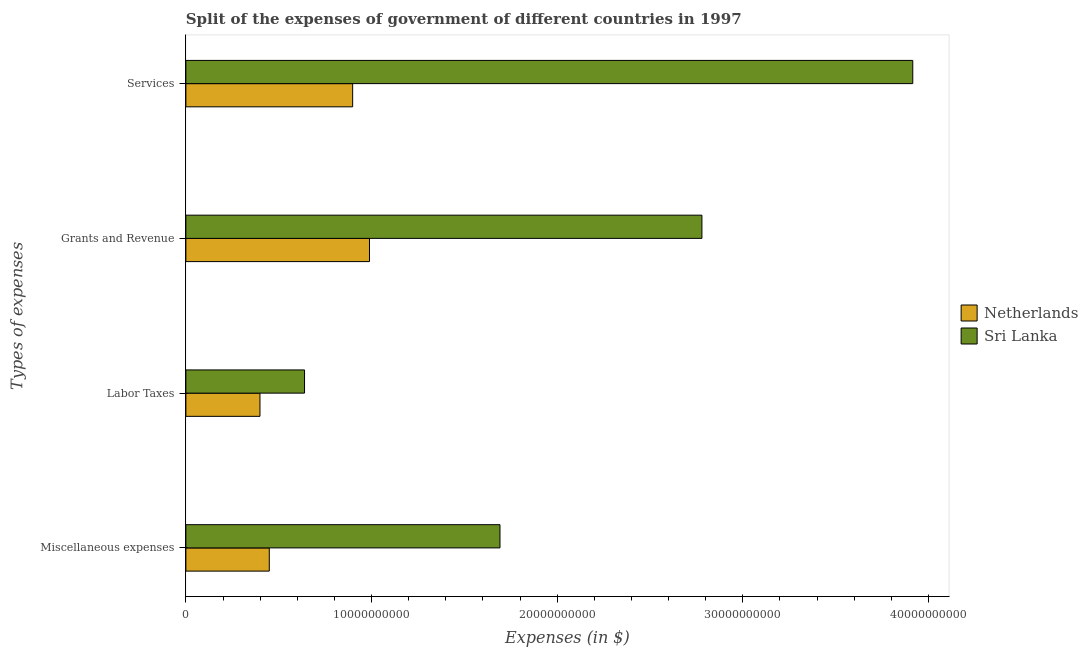How many different coloured bars are there?
Provide a succinct answer. 2. How many groups of bars are there?
Make the answer very short. 4. How many bars are there on the 3rd tick from the top?
Make the answer very short. 2. What is the label of the 1st group of bars from the top?
Keep it short and to the point. Services. What is the amount spent on grants and revenue in Sri Lanka?
Offer a very short reply. 2.78e+1. Across all countries, what is the maximum amount spent on miscellaneous expenses?
Ensure brevity in your answer.  1.69e+1. Across all countries, what is the minimum amount spent on labor taxes?
Provide a short and direct response. 3.99e+09. In which country was the amount spent on grants and revenue maximum?
Ensure brevity in your answer.  Sri Lanka. In which country was the amount spent on services minimum?
Make the answer very short. Netherlands. What is the total amount spent on labor taxes in the graph?
Offer a terse response. 1.04e+1. What is the difference between the amount spent on services in Sri Lanka and that in Netherlands?
Provide a succinct answer. 3.02e+1. What is the difference between the amount spent on miscellaneous expenses in Sri Lanka and the amount spent on labor taxes in Netherlands?
Give a very brief answer. 1.29e+1. What is the average amount spent on miscellaneous expenses per country?
Give a very brief answer. 1.07e+1. What is the difference between the amount spent on miscellaneous expenses and amount spent on grants and revenue in Sri Lanka?
Your answer should be compact. -1.09e+1. What is the ratio of the amount spent on grants and revenue in Netherlands to that in Sri Lanka?
Offer a terse response. 0.36. Is the amount spent on services in Netherlands less than that in Sri Lanka?
Your answer should be very brief. Yes. What is the difference between the highest and the second highest amount spent on miscellaneous expenses?
Provide a short and direct response. 1.24e+1. What is the difference between the highest and the lowest amount spent on miscellaneous expenses?
Your answer should be compact. 1.24e+1. In how many countries, is the amount spent on services greater than the average amount spent on services taken over all countries?
Your answer should be compact. 1. What does the 2nd bar from the top in Grants and Revenue represents?
Keep it short and to the point. Netherlands. Are all the bars in the graph horizontal?
Offer a terse response. Yes. How many countries are there in the graph?
Your response must be concise. 2. Are the values on the major ticks of X-axis written in scientific E-notation?
Make the answer very short. No. Does the graph contain any zero values?
Your answer should be compact. No. Where does the legend appear in the graph?
Make the answer very short. Center right. How many legend labels are there?
Provide a succinct answer. 2. What is the title of the graph?
Keep it short and to the point. Split of the expenses of government of different countries in 1997. Does "Australia" appear as one of the legend labels in the graph?
Your answer should be compact. No. What is the label or title of the X-axis?
Make the answer very short. Expenses (in $). What is the label or title of the Y-axis?
Keep it short and to the point. Types of expenses. What is the Expenses (in $) in Netherlands in Miscellaneous expenses?
Offer a very short reply. 4.49e+09. What is the Expenses (in $) of Sri Lanka in Miscellaneous expenses?
Give a very brief answer. 1.69e+1. What is the Expenses (in $) in Netherlands in Labor Taxes?
Ensure brevity in your answer.  3.99e+09. What is the Expenses (in $) of Sri Lanka in Labor Taxes?
Your answer should be compact. 6.39e+09. What is the Expenses (in $) of Netherlands in Grants and Revenue?
Ensure brevity in your answer.  9.89e+09. What is the Expenses (in $) of Sri Lanka in Grants and Revenue?
Provide a short and direct response. 2.78e+1. What is the Expenses (in $) of Netherlands in Services?
Ensure brevity in your answer.  8.98e+09. What is the Expenses (in $) in Sri Lanka in Services?
Offer a terse response. 3.92e+1. Across all Types of expenses, what is the maximum Expenses (in $) in Netherlands?
Ensure brevity in your answer.  9.89e+09. Across all Types of expenses, what is the maximum Expenses (in $) of Sri Lanka?
Offer a very short reply. 3.92e+1. Across all Types of expenses, what is the minimum Expenses (in $) of Netherlands?
Keep it short and to the point. 3.99e+09. Across all Types of expenses, what is the minimum Expenses (in $) of Sri Lanka?
Your answer should be very brief. 6.39e+09. What is the total Expenses (in $) of Netherlands in the graph?
Provide a short and direct response. 2.74e+1. What is the total Expenses (in $) in Sri Lanka in the graph?
Your answer should be very brief. 9.03e+1. What is the difference between the Expenses (in $) in Netherlands in Miscellaneous expenses and that in Labor Taxes?
Your answer should be compact. 5.02e+08. What is the difference between the Expenses (in $) of Sri Lanka in Miscellaneous expenses and that in Labor Taxes?
Make the answer very short. 1.05e+1. What is the difference between the Expenses (in $) in Netherlands in Miscellaneous expenses and that in Grants and Revenue?
Provide a succinct answer. -5.40e+09. What is the difference between the Expenses (in $) of Sri Lanka in Miscellaneous expenses and that in Grants and Revenue?
Your answer should be compact. -1.09e+1. What is the difference between the Expenses (in $) of Netherlands in Miscellaneous expenses and that in Services?
Give a very brief answer. -4.49e+09. What is the difference between the Expenses (in $) in Sri Lanka in Miscellaneous expenses and that in Services?
Give a very brief answer. -2.22e+1. What is the difference between the Expenses (in $) of Netherlands in Labor Taxes and that in Grants and Revenue?
Ensure brevity in your answer.  -5.90e+09. What is the difference between the Expenses (in $) of Sri Lanka in Labor Taxes and that in Grants and Revenue?
Keep it short and to the point. -2.14e+1. What is the difference between the Expenses (in $) in Netherlands in Labor Taxes and that in Services?
Your answer should be very brief. -4.99e+09. What is the difference between the Expenses (in $) in Sri Lanka in Labor Taxes and that in Services?
Give a very brief answer. -3.28e+1. What is the difference between the Expenses (in $) in Netherlands in Grants and Revenue and that in Services?
Keep it short and to the point. 9.07e+08. What is the difference between the Expenses (in $) in Sri Lanka in Grants and Revenue and that in Services?
Offer a very short reply. -1.14e+1. What is the difference between the Expenses (in $) of Netherlands in Miscellaneous expenses and the Expenses (in $) of Sri Lanka in Labor Taxes?
Give a very brief answer. -1.90e+09. What is the difference between the Expenses (in $) in Netherlands in Miscellaneous expenses and the Expenses (in $) in Sri Lanka in Grants and Revenue?
Offer a very short reply. -2.33e+1. What is the difference between the Expenses (in $) of Netherlands in Miscellaneous expenses and the Expenses (in $) of Sri Lanka in Services?
Make the answer very short. -3.47e+1. What is the difference between the Expenses (in $) of Netherlands in Labor Taxes and the Expenses (in $) of Sri Lanka in Grants and Revenue?
Offer a very short reply. -2.38e+1. What is the difference between the Expenses (in $) in Netherlands in Labor Taxes and the Expenses (in $) in Sri Lanka in Services?
Your response must be concise. -3.52e+1. What is the difference between the Expenses (in $) in Netherlands in Grants and Revenue and the Expenses (in $) in Sri Lanka in Services?
Offer a terse response. -2.93e+1. What is the average Expenses (in $) in Netherlands per Types of expenses?
Offer a very short reply. 6.84e+09. What is the average Expenses (in $) of Sri Lanka per Types of expenses?
Provide a short and direct response. 2.26e+1. What is the difference between the Expenses (in $) in Netherlands and Expenses (in $) in Sri Lanka in Miscellaneous expenses?
Provide a succinct answer. -1.24e+1. What is the difference between the Expenses (in $) in Netherlands and Expenses (in $) in Sri Lanka in Labor Taxes?
Your answer should be compact. -2.40e+09. What is the difference between the Expenses (in $) of Netherlands and Expenses (in $) of Sri Lanka in Grants and Revenue?
Your answer should be very brief. -1.79e+1. What is the difference between the Expenses (in $) in Netherlands and Expenses (in $) in Sri Lanka in Services?
Your response must be concise. -3.02e+1. What is the ratio of the Expenses (in $) in Netherlands in Miscellaneous expenses to that in Labor Taxes?
Your response must be concise. 1.13. What is the ratio of the Expenses (in $) of Sri Lanka in Miscellaneous expenses to that in Labor Taxes?
Offer a very short reply. 2.65. What is the ratio of the Expenses (in $) of Netherlands in Miscellaneous expenses to that in Grants and Revenue?
Give a very brief answer. 0.45. What is the ratio of the Expenses (in $) of Sri Lanka in Miscellaneous expenses to that in Grants and Revenue?
Make the answer very short. 0.61. What is the ratio of the Expenses (in $) of Netherlands in Miscellaneous expenses to that in Services?
Your answer should be very brief. 0.5. What is the ratio of the Expenses (in $) of Sri Lanka in Miscellaneous expenses to that in Services?
Your answer should be compact. 0.43. What is the ratio of the Expenses (in $) in Netherlands in Labor Taxes to that in Grants and Revenue?
Offer a terse response. 0.4. What is the ratio of the Expenses (in $) in Sri Lanka in Labor Taxes to that in Grants and Revenue?
Your answer should be very brief. 0.23. What is the ratio of the Expenses (in $) in Netherlands in Labor Taxes to that in Services?
Offer a terse response. 0.44. What is the ratio of the Expenses (in $) of Sri Lanka in Labor Taxes to that in Services?
Provide a succinct answer. 0.16. What is the ratio of the Expenses (in $) in Netherlands in Grants and Revenue to that in Services?
Give a very brief answer. 1.1. What is the ratio of the Expenses (in $) of Sri Lanka in Grants and Revenue to that in Services?
Your answer should be compact. 0.71. What is the difference between the highest and the second highest Expenses (in $) of Netherlands?
Provide a short and direct response. 9.07e+08. What is the difference between the highest and the second highest Expenses (in $) in Sri Lanka?
Your answer should be compact. 1.14e+1. What is the difference between the highest and the lowest Expenses (in $) of Netherlands?
Your answer should be very brief. 5.90e+09. What is the difference between the highest and the lowest Expenses (in $) of Sri Lanka?
Ensure brevity in your answer.  3.28e+1. 